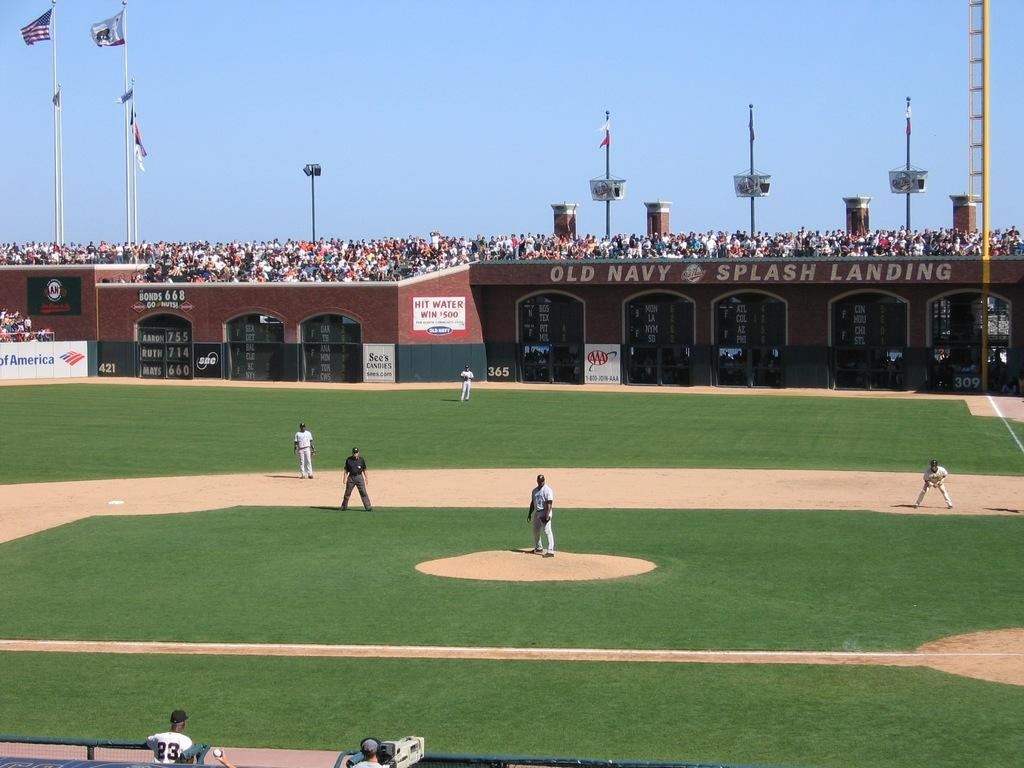<image>
Provide a brief description of the given image. Players compete on a baseball diamond under the name OLD NAVY SPLASH LANDING. 